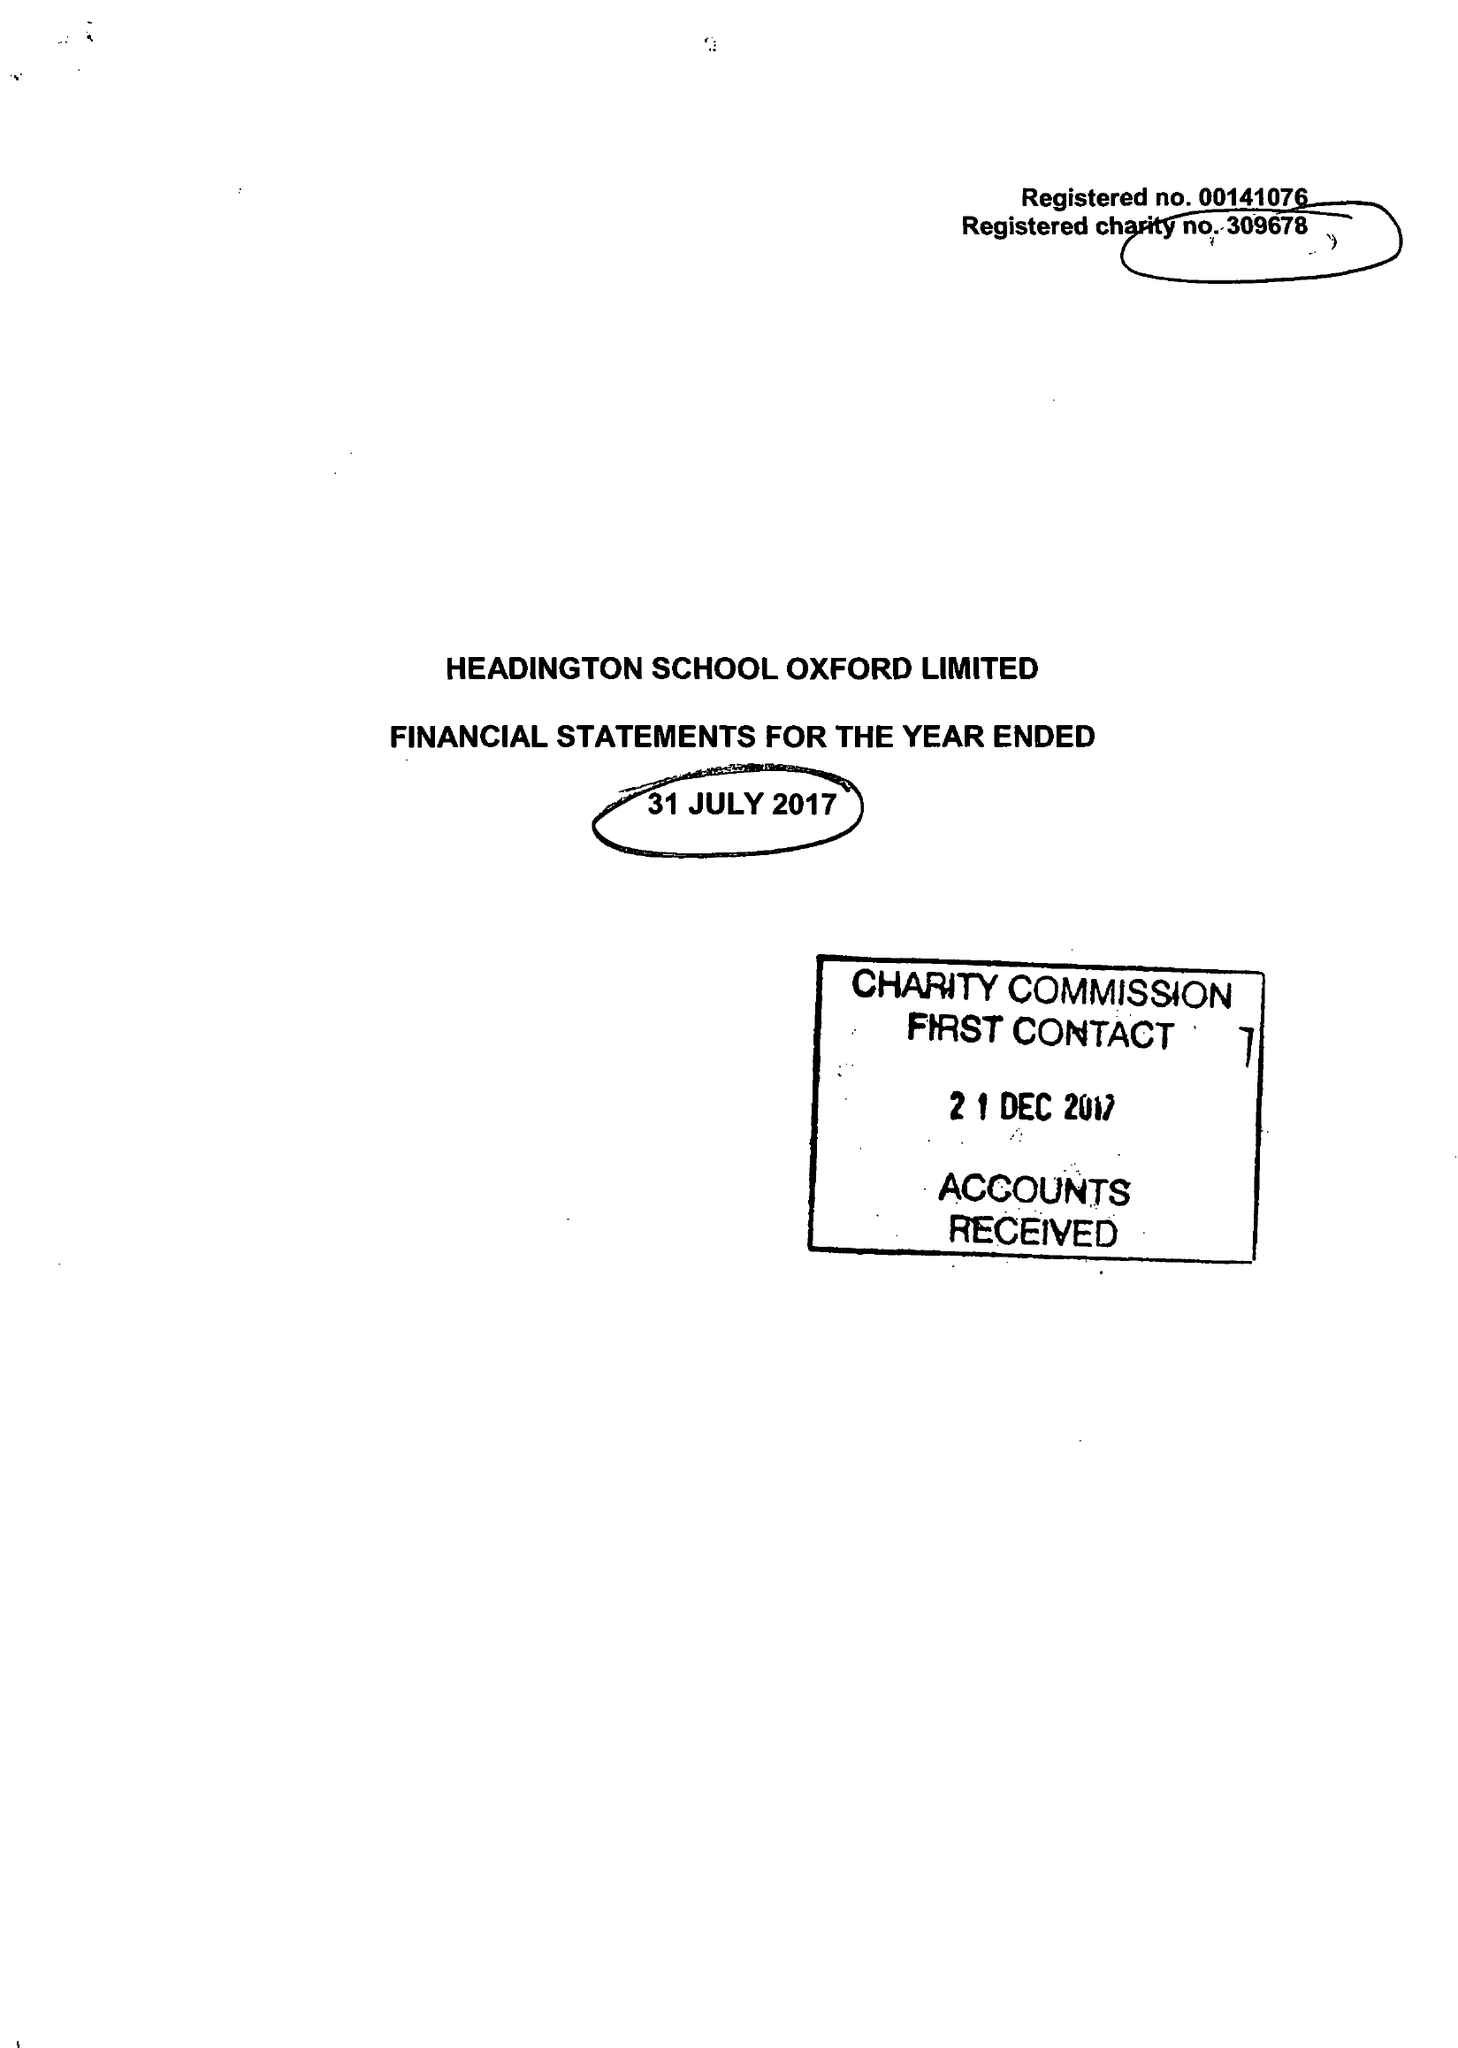What is the value for the report_date?
Answer the question using a single word or phrase. 2017-07-31 